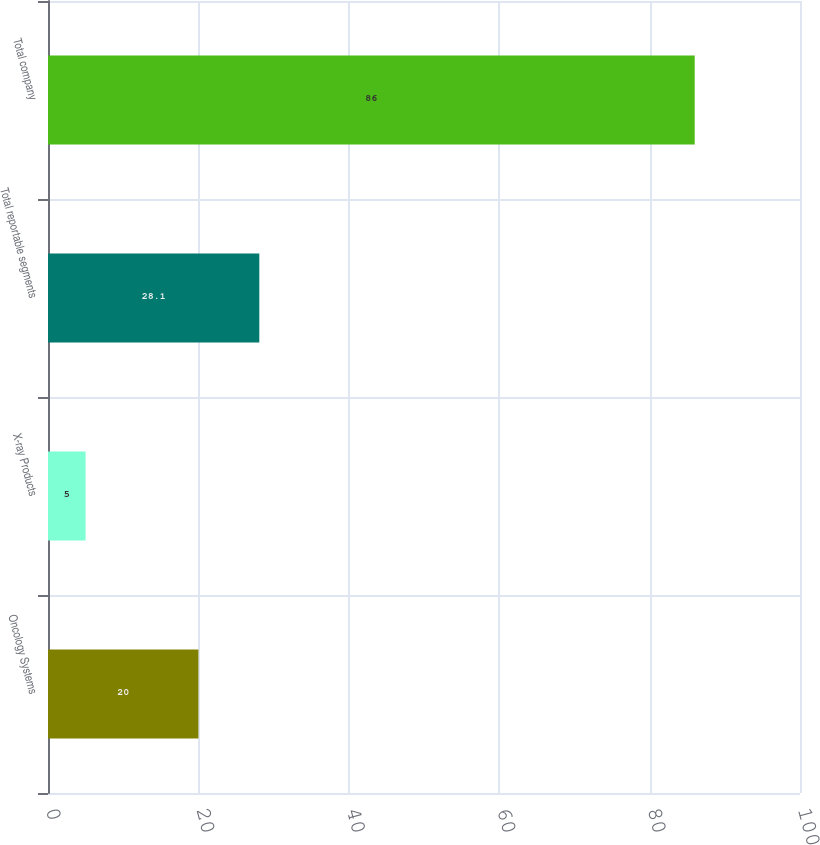<chart> <loc_0><loc_0><loc_500><loc_500><bar_chart><fcel>Oncology Systems<fcel>X-ray Products<fcel>Total reportable segments<fcel>Total company<nl><fcel>20<fcel>5<fcel>28.1<fcel>86<nl></chart> 